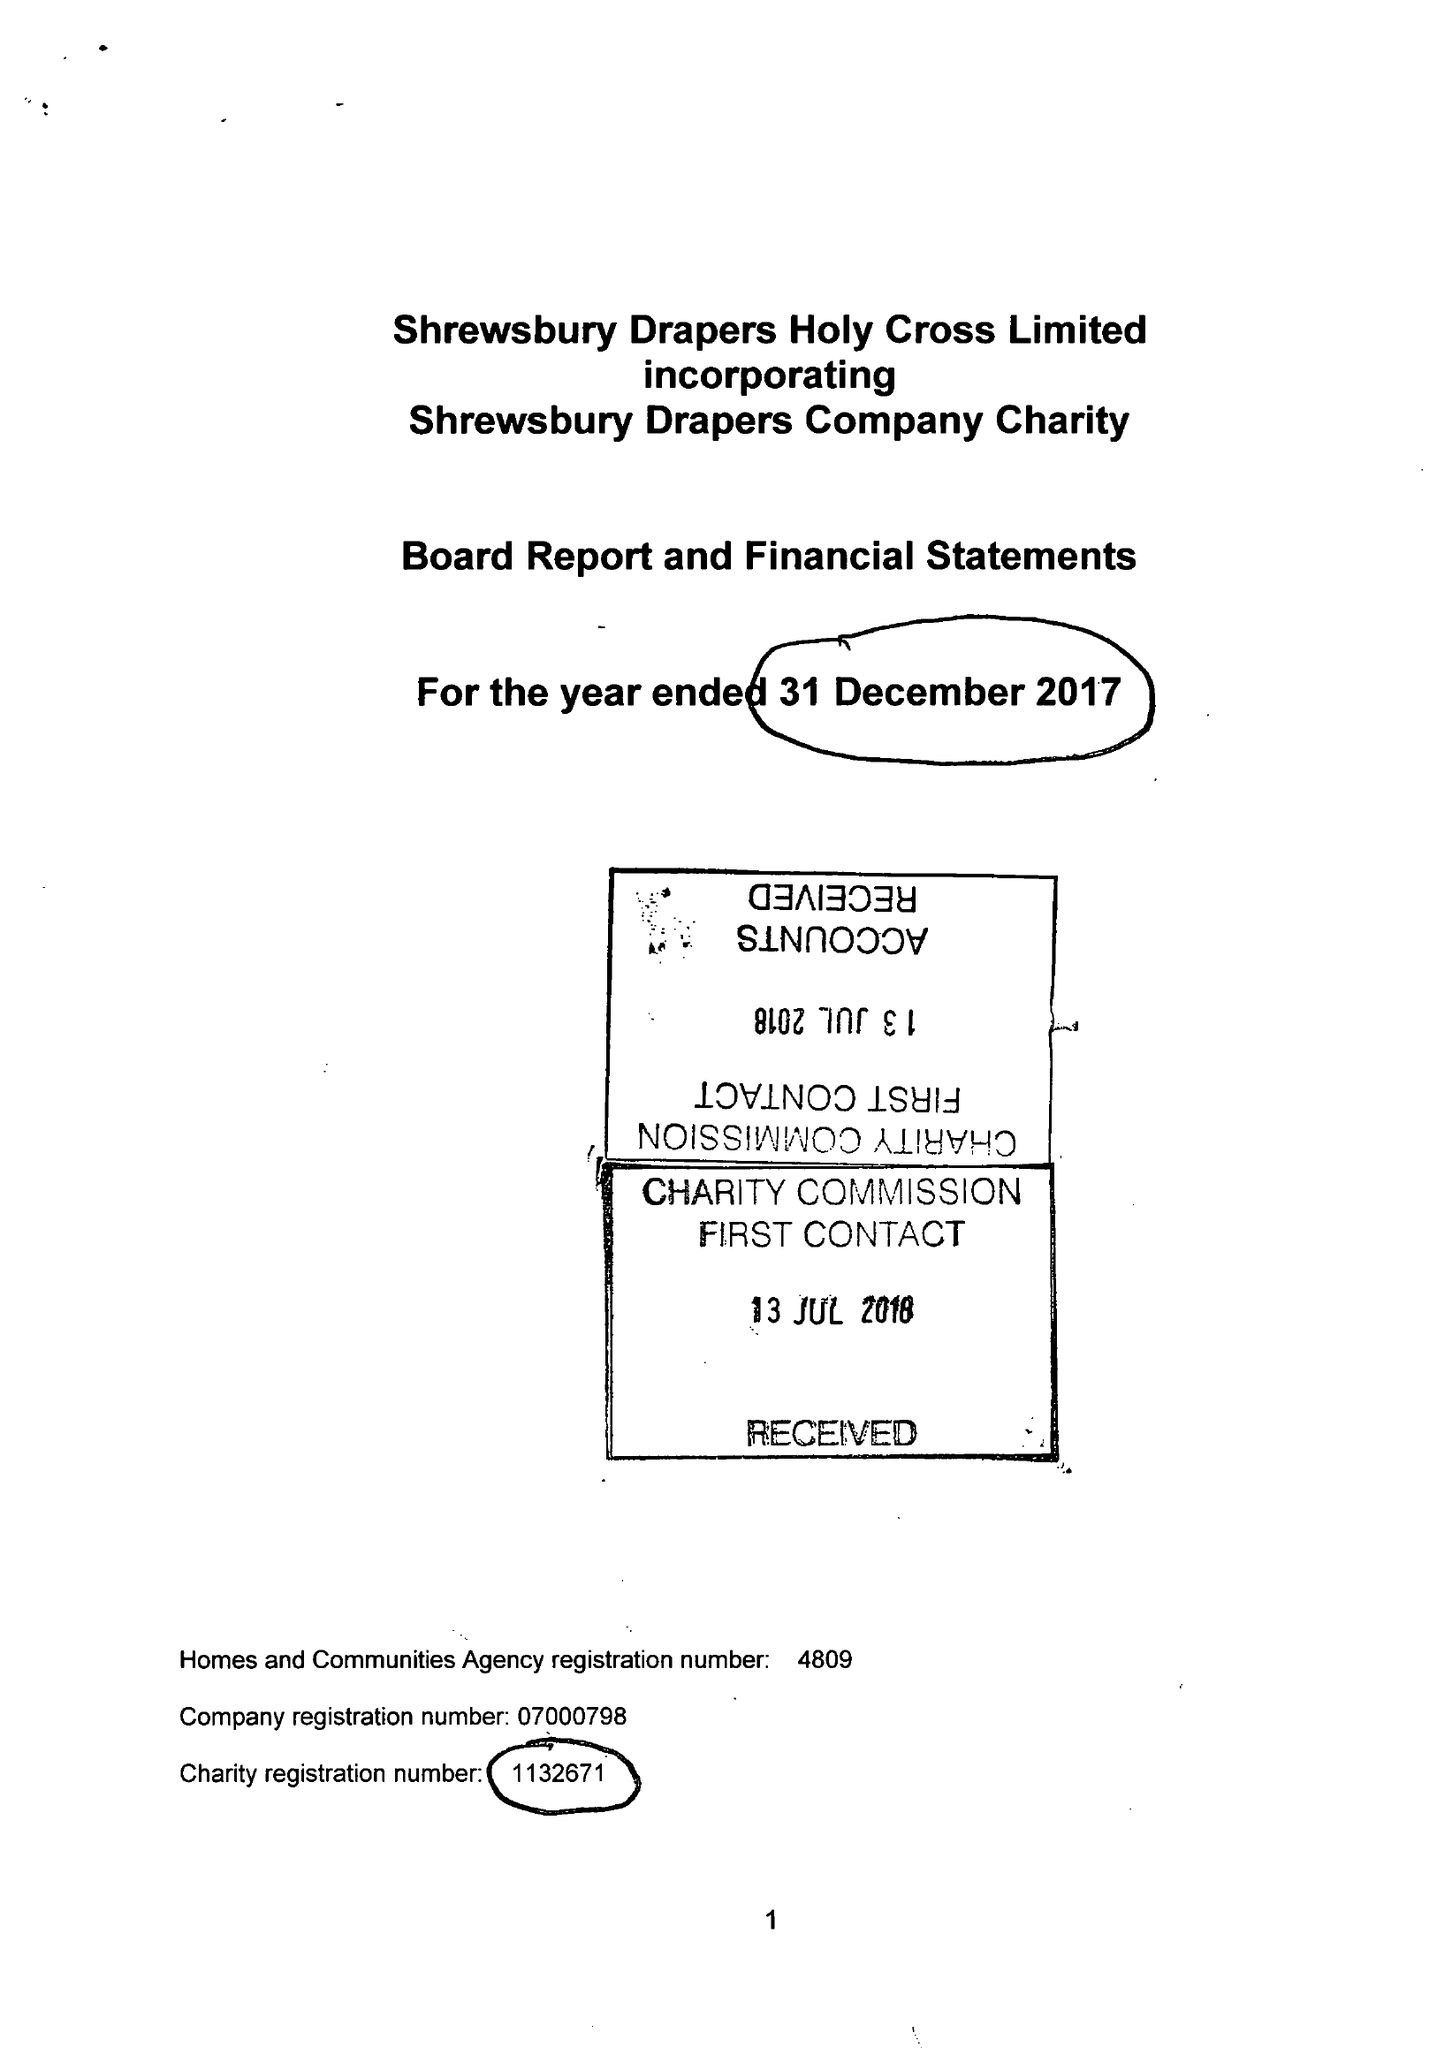What is the value for the spending_annually_in_british_pounds?
Answer the question using a single word or phrase. 244041.00 